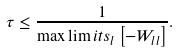Convert formula to latex. <formula><loc_0><loc_0><loc_500><loc_500>\tau \leq \frac { 1 } { \max \lim i t s _ { l } \left [ - W _ { l l } \right ] } .</formula> 